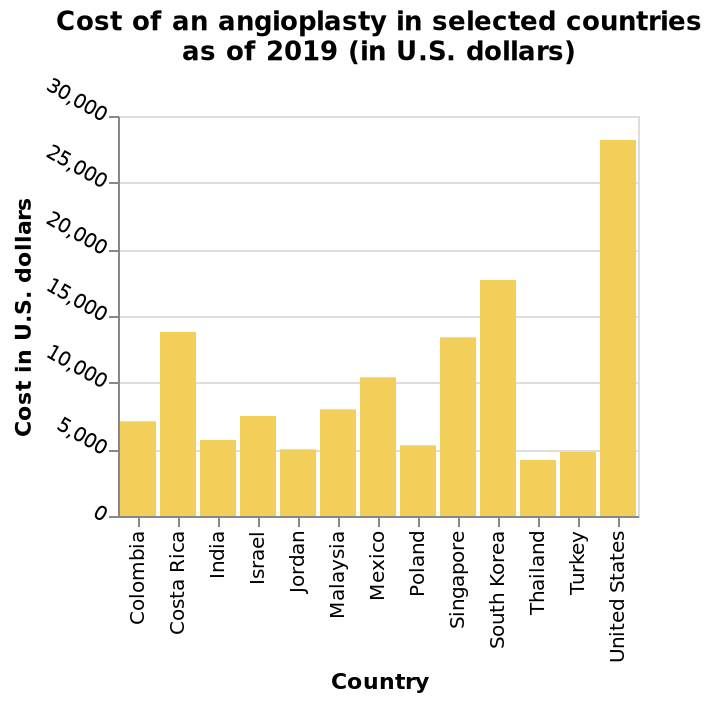<image>
Which country is represented as the starting point on the x-axis of the bar diagram? The starting point on the x-axis of the bar diagram is Colombia. please describe the details of the chart This is a bar diagram labeled Cost of an angioplasty in selected countries as of 2019 (in U.S. dollars). The x-axis shows Country using categorical scale from Colombia to United States while the y-axis plots Cost in U.S. dollars on linear scale from 0 to 30,000. Is the United States the cheapest country for angioplasty surgery? No, the United States is the most expensive country on the chart for angioplasty surgery. What is the United States' ranking on the chart for angioplasty surgery costs? The United States is the most expensive country on the chart for angioplasty surgery. Is the ending point on the x-axis of the bar diagram Colombia? No.The starting point on the x-axis of the bar diagram is Colombia. 